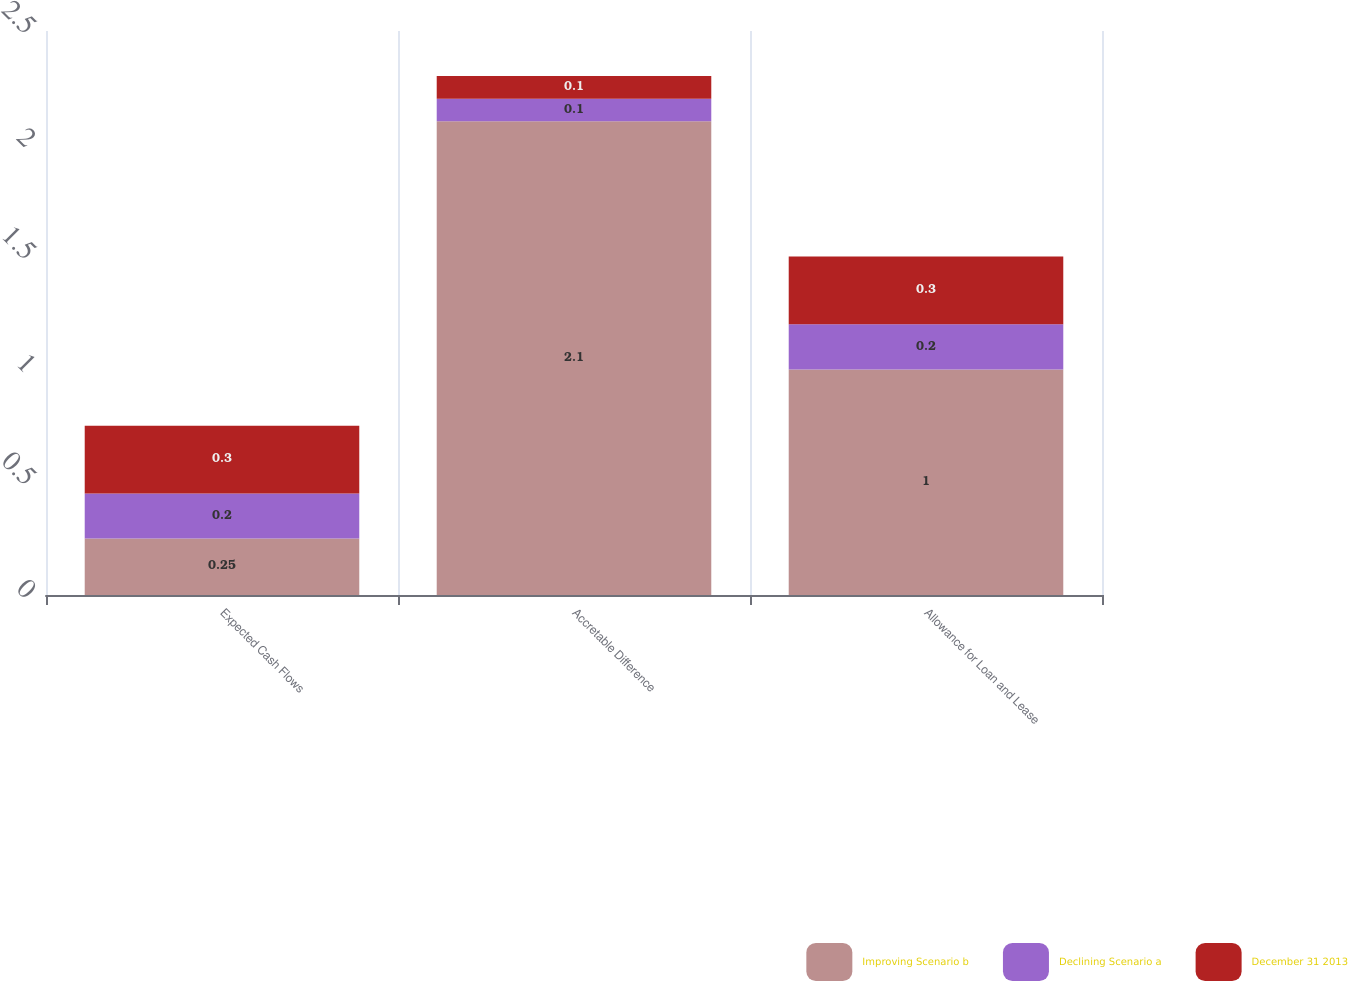Convert chart to OTSL. <chart><loc_0><loc_0><loc_500><loc_500><stacked_bar_chart><ecel><fcel>Expected Cash Flows<fcel>Accretable Difference<fcel>Allowance for Loan and Lease<nl><fcel>Improving Scenario b<fcel>0.25<fcel>2.1<fcel>1<nl><fcel>Declining Scenario a<fcel>0.2<fcel>0.1<fcel>0.2<nl><fcel>December 31 2013<fcel>0.3<fcel>0.1<fcel>0.3<nl></chart> 